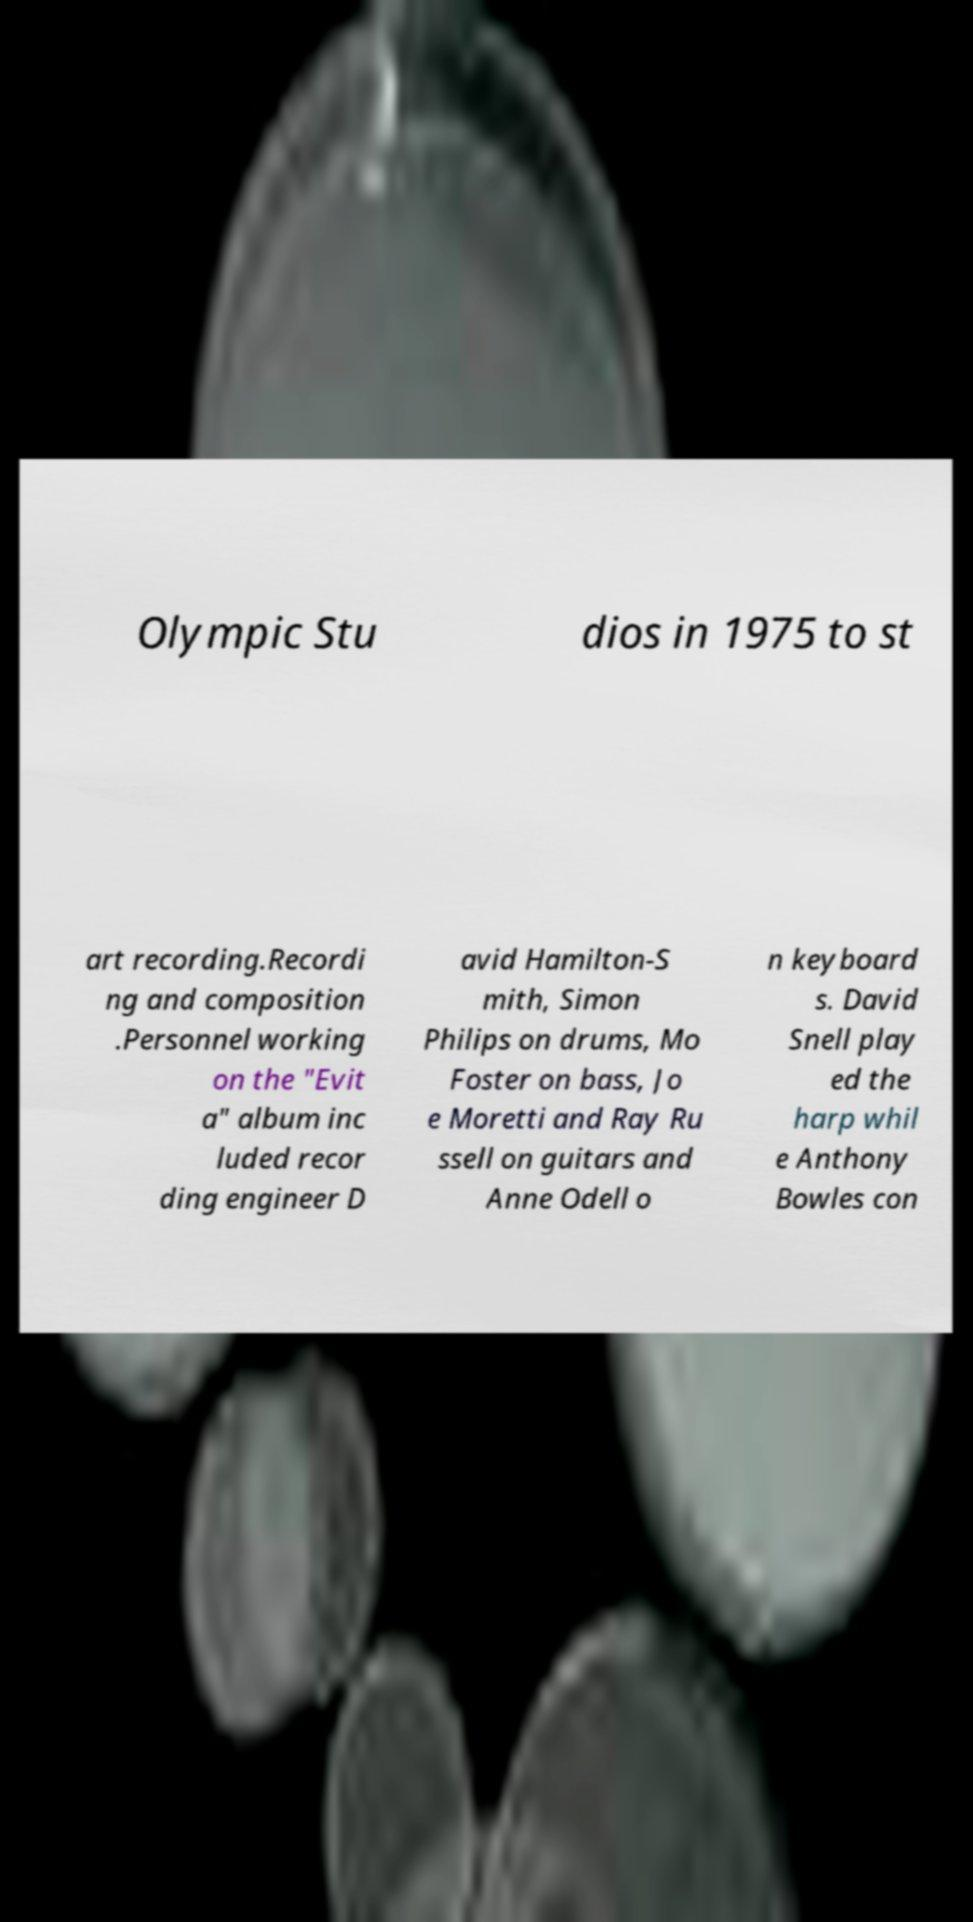I need the written content from this picture converted into text. Can you do that? Olympic Stu dios in 1975 to st art recording.Recordi ng and composition .Personnel working on the "Evit a" album inc luded recor ding engineer D avid Hamilton-S mith, Simon Philips on drums, Mo Foster on bass, Jo e Moretti and Ray Ru ssell on guitars and Anne Odell o n keyboard s. David Snell play ed the harp whil e Anthony Bowles con 